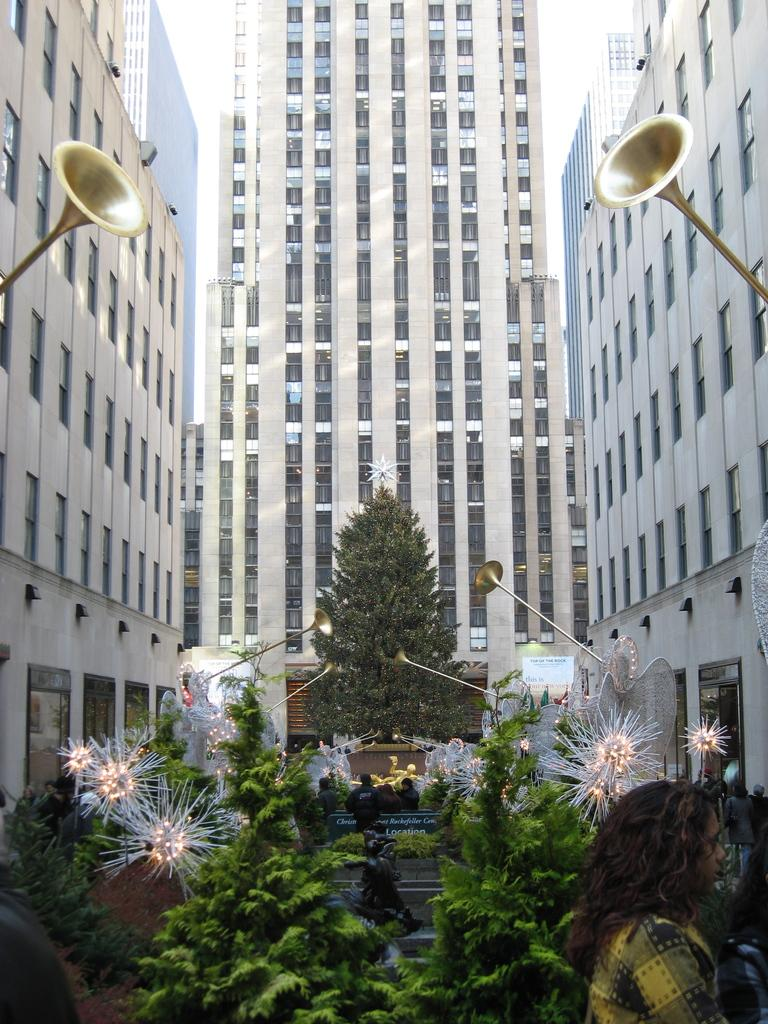What type of structures are visible on the sides of the image? There are buildings with windows on the sides of the image. What can be seen on the ground in the image? There are trees and people on the ground in the image. What is visible in the background of the image? There is a building in the background of the image. What additional items can be found in the image? Some decorative items are present in the image. How many children are playing in the shop in the image? There is no shop or children present in the image. What type of copy is being made in the image? There is no copying or duplication activity taking place in the image. 